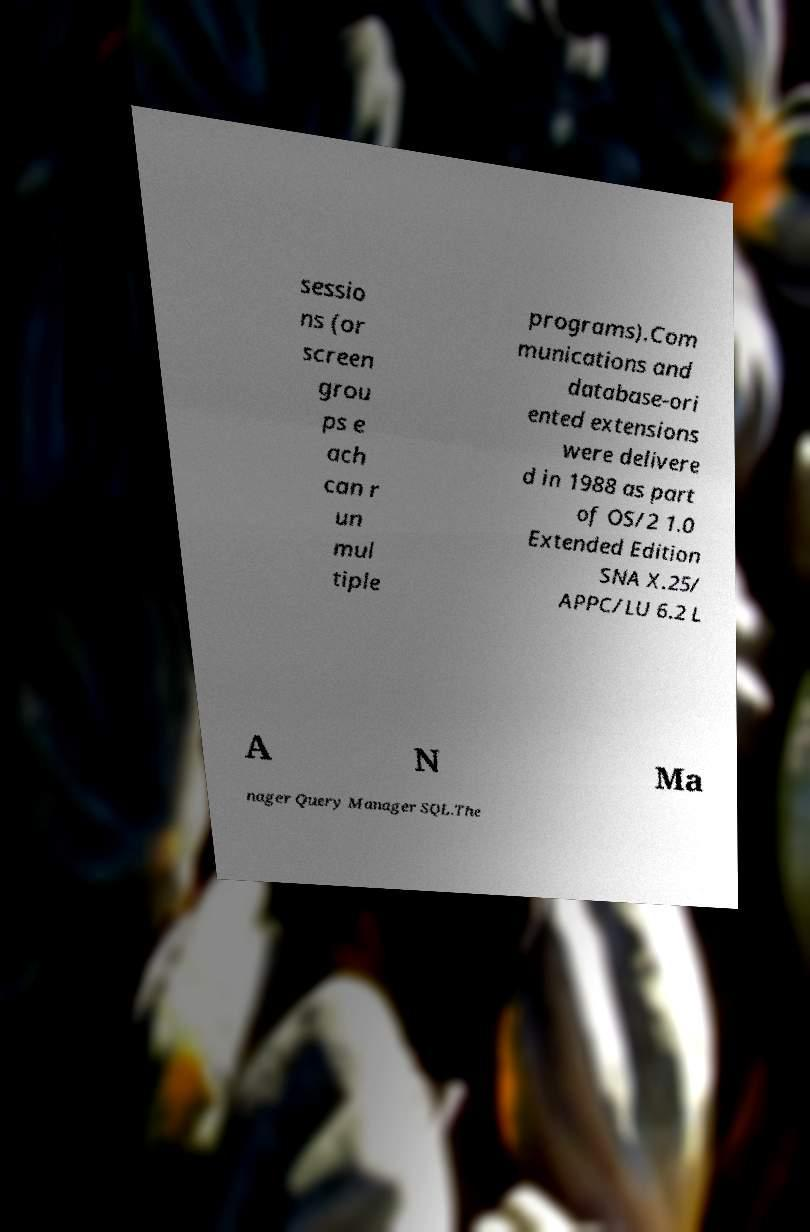Could you extract and type out the text from this image? sessio ns (or screen grou ps e ach can r un mul tiple programs).Com munications and database-ori ented extensions were delivere d in 1988 as part of OS/2 1.0 Extended Edition SNA X.25/ APPC/LU 6.2 L A N Ma nager Query Manager SQL.The 